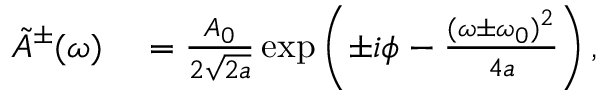Convert formula to latex. <formula><loc_0><loc_0><loc_500><loc_500>\begin{array} { r l } { \tilde { A } ^ { \pm } ( \omega ) } & = \frac { A _ { 0 } } { 2 \sqrt { 2 a } } \exp \left ( \pm i \phi - \frac { ( \omega \pm \omega _ { 0 } ) ^ { 2 } } { 4 a } \right ) , } \end{array}</formula> 